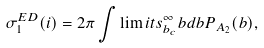<formula> <loc_0><loc_0><loc_500><loc_500>\sigma ^ { E D } _ { 1 } ( i ) = 2 \pi \int \lim i t s _ { b _ { c } } ^ { \infty } b d b P _ { A _ { 2 } } ( b ) ,</formula> 